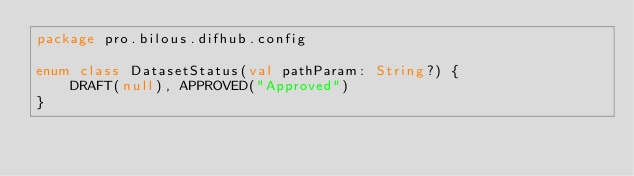<code> <loc_0><loc_0><loc_500><loc_500><_Kotlin_>package pro.bilous.difhub.config

enum class DatasetStatus(val pathParam: String?) {
	DRAFT(null), APPROVED("Approved")
}
</code> 